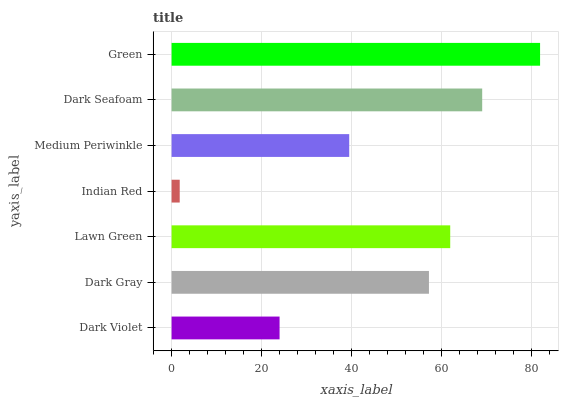Is Indian Red the minimum?
Answer yes or no. Yes. Is Green the maximum?
Answer yes or no. Yes. Is Dark Gray the minimum?
Answer yes or no. No. Is Dark Gray the maximum?
Answer yes or no. No. Is Dark Gray greater than Dark Violet?
Answer yes or no. Yes. Is Dark Violet less than Dark Gray?
Answer yes or no. Yes. Is Dark Violet greater than Dark Gray?
Answer yes or no. No. Is Dark Gray less than Dark Violet?
Answer yes or no. No. Is Dark Gray the high median?
Answer yes or no. Yes. Is Dark Gray the low median?
Answer yes or no. Yes. Is Lawn Green the high median?
Answer yes or no. No. Is Green the low median?
Answer yes or no. No. 